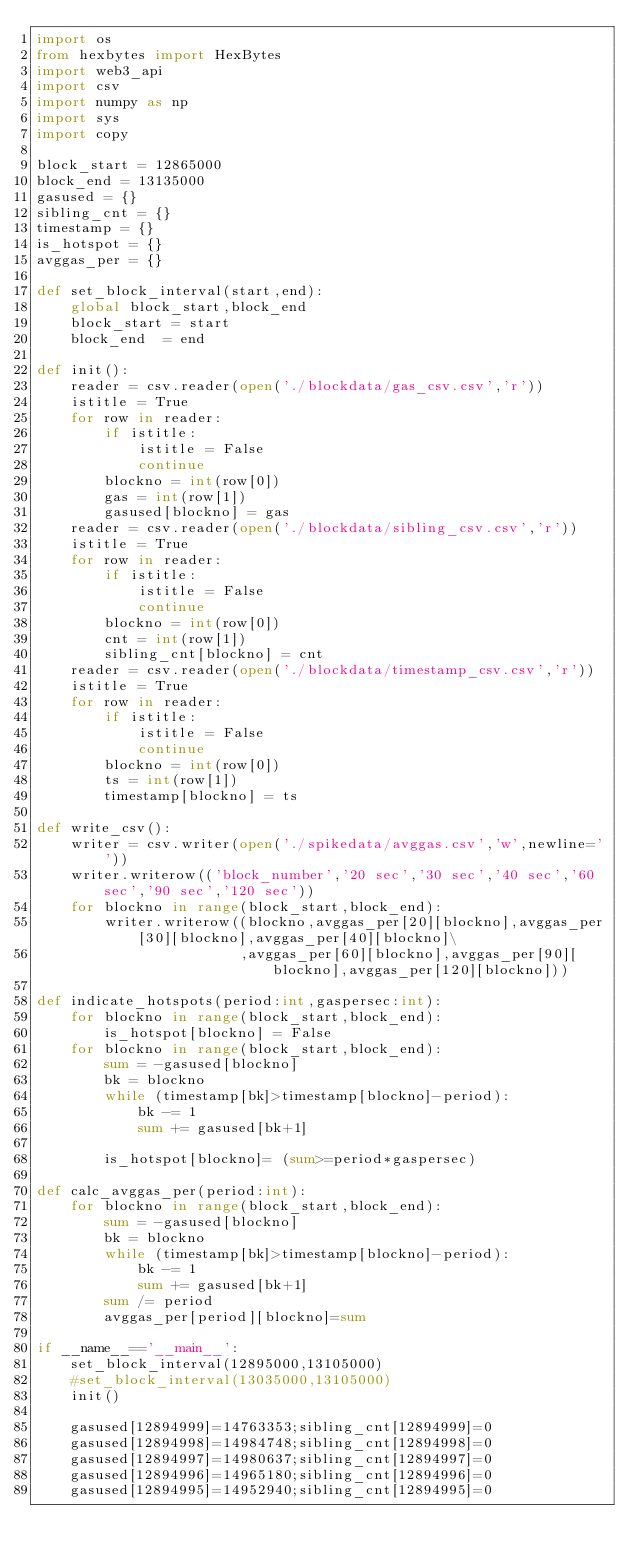Convert code to text. <code><loc_0><loc_0><loc_500><loc_500><_Python_>import os
from hexbytes import HexBytes
import web3_api
import csv
import numpy as np
import sys
import copy

block_start = 12865000
block_end = 13135000
gasused = {}
sibling_cnt = {}
timestamp = {}
is_hotspot = {}
avggas_per = {}

def set_block_interval(start,end):
    global block_start,block_end
    block_start = start
    block_end  = end

def init():
    reader = csv.reader(open('./blockdata/gas_csv.csv','r'))
    istitle = True
    for row in reader:
        if istitle:
            istitle = False
            continue
        blockno = int(row[0])
        gas = int(row[1])
        gasused[blockno] = gas
    reader = csv.reader(open('./blockdata/sibling_csv.csv','r'))
    istitle = True
    for row in reader:
        if istitle:
            istitle = False
            continue
        blockno = int(row[0])
        cnt = int(row[1])
        sibling_cnt[blockno] = cnt
    reader = csv.reader(open('./blockdata/timestamp_csv.csv','r'))
    istitle = True
    for row in reader:
        if istitle:
            istitle = False
            continue
        blockno = int(row[0])
        ts = int(row[1])
        timestamp[blockno] = ts

def write_csv():
    writer = csv.writer(open('./spikedata/avggas.csv','w',newline=''))
    writer.writerow(('block_number','20 sec','30 sec','40 sec','60 sec','90 sec','120 sec'))
    for blockno in range(block_start,block_end):
        writer.writerow((blockno,avggas_per[20][blockno],avggas_per[30][blockno],avggas_per[40][blockno]\
                        ,avggas_per[60][blockno],avggas_per[90][blockno],avggas_per[120][blockno]))
        
def indicate_hotspots(period:int,gaspersec:int):
    for blockno in range(block_start,block_end):
        is_hotspot[blockno] = False
    for blockno in range(block_start,block_end):
        sum = -gasused[blockno]
        bk = blockno
        while (timestamp[bk]>timestamp[blockno]-period):
            bk -= 1
            sum += gasused[bk+1]

        is_hotspot[blockno]= (sum>=period*gaspersec)

def calc_avggas_per(period:int):
    for blockno in range(block_start,block_end):
        sum = -gasused[blockno]
        bk = blockno
        while (timestamp[bk]>timestamp[blockno]-period):
            bk -= 1
            sum += gasused[bk+1]
        sum /= period
        avggas_per[period][blockno]=sum

if __name__=='__main__':
    set_block_interval(12895000,13105000)
    #set_block_interval(13035000,13105000)
    init()

    gasused[12894999]=14763353;sibling_cnt[12894999]=0
    gasused[12894998]=14984748;sibling_cnt[12894998]=0
    gasused[12894997]=14980637;sibling_cnt[12894997]=0
    gasused[12894996]=14965180;sibling_cnt[12894996]=0
    gasused[12894995]=14952940;sibling_cnt[12894995]=0</code> 